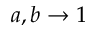Convert formula to latex. <formula><loc_0><loc_0><loc_500><loc_500>a , b \rightarrow 1</formula> 